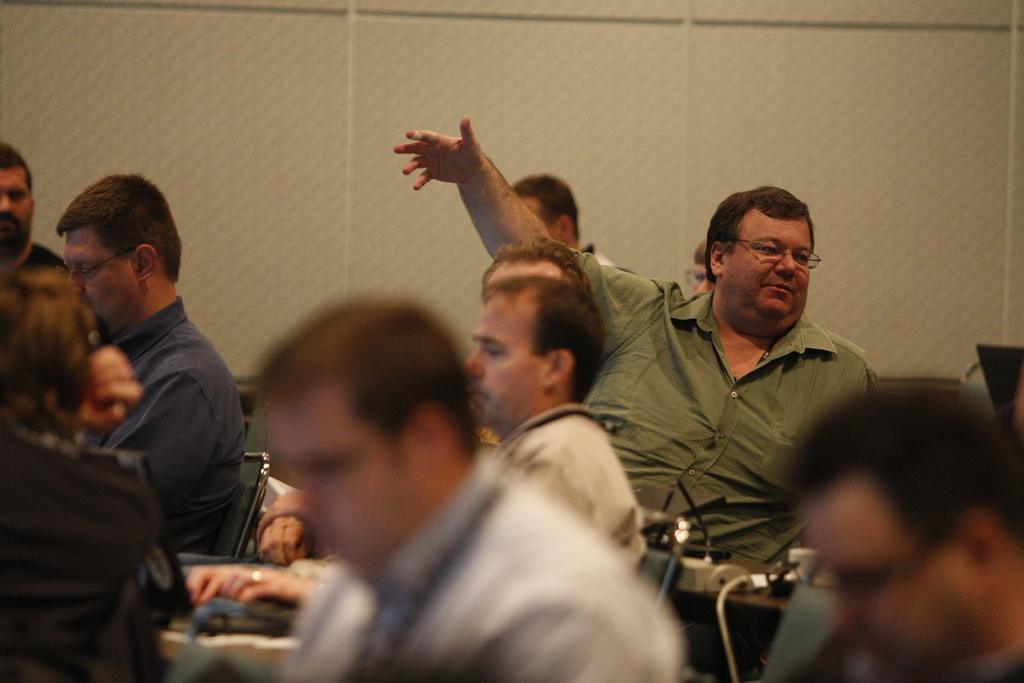What are the men in the image doing? The men in the image are sitting on chairs. What direction are the men looking in the image? The men are staring in the front. What can be seen behind the men in the image? There is a wall in the back of the image. How many goats are standing next to the men in the image? There are no goats present in the image. Are the men's sisters sitting with them in the image? The provided facts do not mention anything about the men's sisters, so we cannot determine if they are present in the image. 